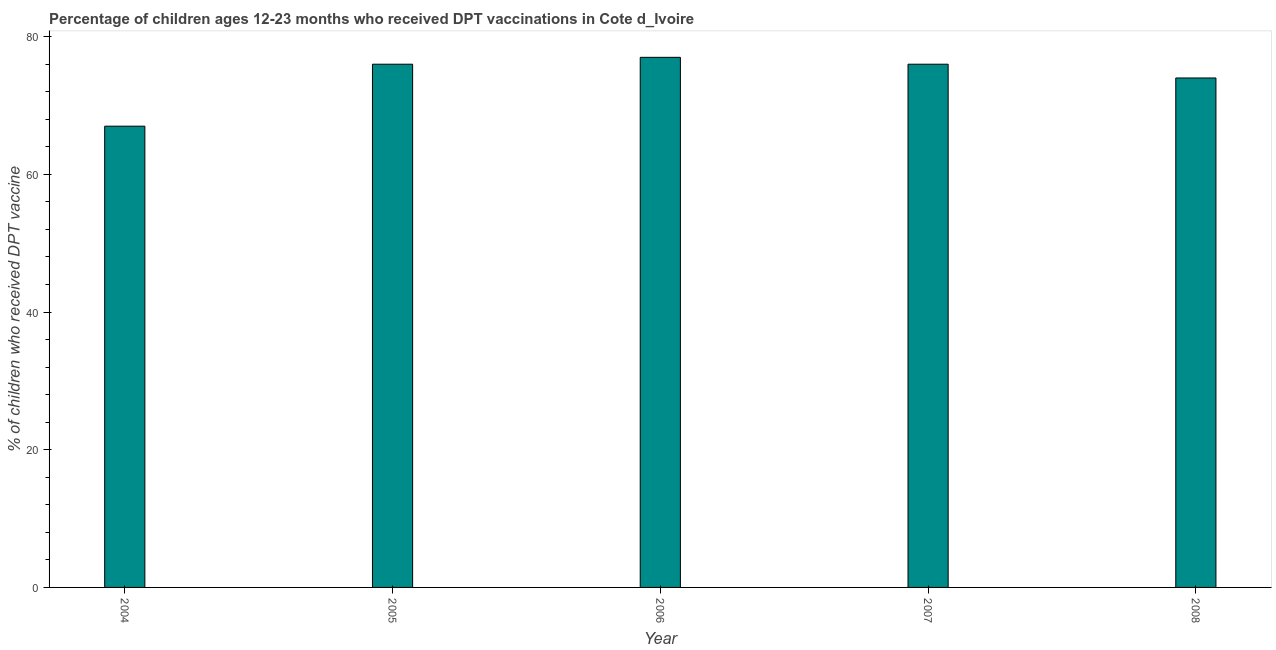What is the title of the graph?
Your answer should be compact. Percentage of children ages 12-23 months who received DPT vaccinations in Cote d_Ivoire. What is the label or title of the X-axis?
Offer a very short reply. Year. What is the label or title of the Y-axis?
Your answer should be compact. % of children who received DPT vaccine. Across all years, what is the maximum percentage of children who received dpt vaccine?
Your answer should be very brief. 77. In which year was the percentage of children who received dpt vaccine maximum?
Your answer should be compact. 2006. What is the sum of the percentage of children who received dpt vaccine?
Provide a succinct answer. 370. What is the difference between the percentage of children who received dpt vaccine in 2004 and 2008?
Provide a succinct answer. -7. What is the average percentage of children who received dpt vaccine per year?
Provide a short and direct response. 74. What is the median percentage of children who received dpt vaccine?
Make the answer very short. 76. Is the percentage of children who received dpt vaccine in 2005 less than that in 2008?
Provide a short and direct response. No. Is the difference between the percentage of children who received dpt vaccine in 2005 and 2006 greater than the difference between any two years?
Keep it short and to the point. No. What is the difference between the highest and the lowest percentage of children who received dpt vaccine?
Make the answer very short. 10. In how many years, is the percentage of children who received dpt vaccine greater than the average percentage of children who received dpt vaccine taken over all years?
Give a very brief answer. 3. Are all the bars in the graph horizontal?
Your answer should be compact. No. What is the difference between two consecutive major ticks on the Y-axis?
Provide a short and direct response. 20. Are the values on the major ticks of Y-axis written in scientific E-notation?
Make the answer very short. No. What is the % of children who received DPT vaccine in 2004?
Provide a succinct answer. 67. What is the % of children who received DPT vaccine of 2007?
Keep it short and to the point. 76. What is the % of children who received DPT vaccine of 2008?
Offer a terse response. 74. What is the difference between the % of children who received DPT vaccine in 2004 and 2008?
Provide a succinct answer. -7. What is the difference between the % of children who received DPT vaccine in 2005 and 2006?
Keep it short and to the point. -1. What is the difference between the % of children who received DPT vaccine in 2005 and 2007?
Give a very brief answer. 0. What is the difference between the % of children who received DPT vaccine in 2006 and 2008?
Provide a short and direct response. 3. What is the ratio of the % of children who received DPT vaccine in 2004 to that in 2005?
Ensure brevity in your answer.  0.88. What is the ratio of the % of children who received DPT vaccine in 2004 to that in 2006?
Your response must be concise. 0.87. What is the ratio of the % of children who received DPT vaccine in 2004 to that in 2007?
Ensure brevity in your answer.  0.88. What is the ratio of the % of children who received DPT vaccine in 2004 to that in 2008?
Your response must be concise. 0.91. What is the ratio of the % of children who received DPT vaccine in 2005 to that in 2007?
Your answer should be compact. 1. What is the ratio of the % of children who received DPT vaccine in 2005 to that in 2008?
Your response must be concise. 1.03. What is the ratio of the % of children who received DPT vaccine in 2006 to that in 2008?
Your answer should be very brief. 1.04. 